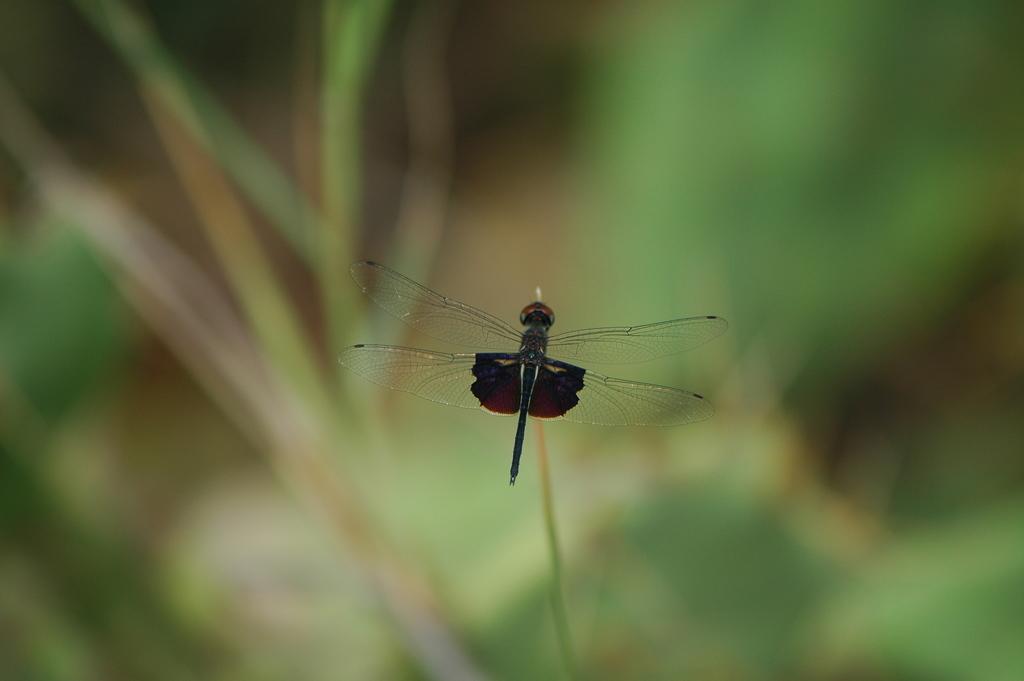How would you summarize this image in a sentence or two? In this picture we can see a dragonfly on the stem and behind the dragonfly there is a blurred background. 